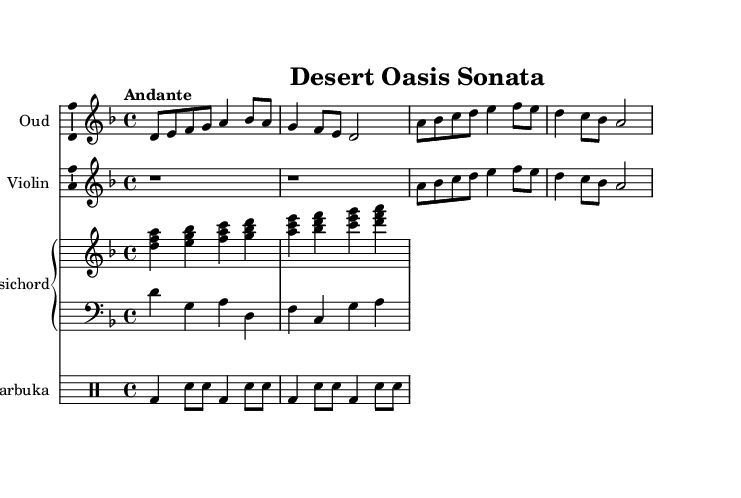What is the key signature of this music? The key signature is indicated by the clef and the initial notes. In this case, there are two flats visible, which corresponds to B flat and E flat, indicating the key of D minor.
Answer: D minor What is the time signature of this music? The time signature is indicated at the beginning of the piece, showing a “4/4” at the start. This tells us each measure has four beats, with each quarter note getting one beat.
Answer: 4/4 What is the tempo marking of this piece? The tempo marking is written above the music, reading “Andante.” This term typically indicates a moderate pace, generally suggesting a walking speed.
Answer: Andante How many instruments are present in this score? The score has four distinct staves, each representing an instrument: Oud, Violin, Harpsichord, and Darbuka. Thus, we count the separate instrumental voices.
Answer: Four Which instrument plays a rhythm section role in this piece? The rhythm section is provided by the Darbuka, which is a percussion instrument played in traditional Middle Eastern music, indicated through its specific rhythm notations.
Answer: Darbuka What is the primary stylistic influence of this composition? The composition blends Baroque and traditional Middle Eastern styles, highlighted by the use of Western instruments like the Harpsichord and traditional instruments like the Oud and Darbuka.
Answer: Baroque-inspired fusion Which section of the music has rests indicated? The rests are indicated in the Violin part at the beginning, where there are two measures of rests before it plays. This is shown by “r1” notation, meaning “rest for one whole note.”
Answer: Violin 